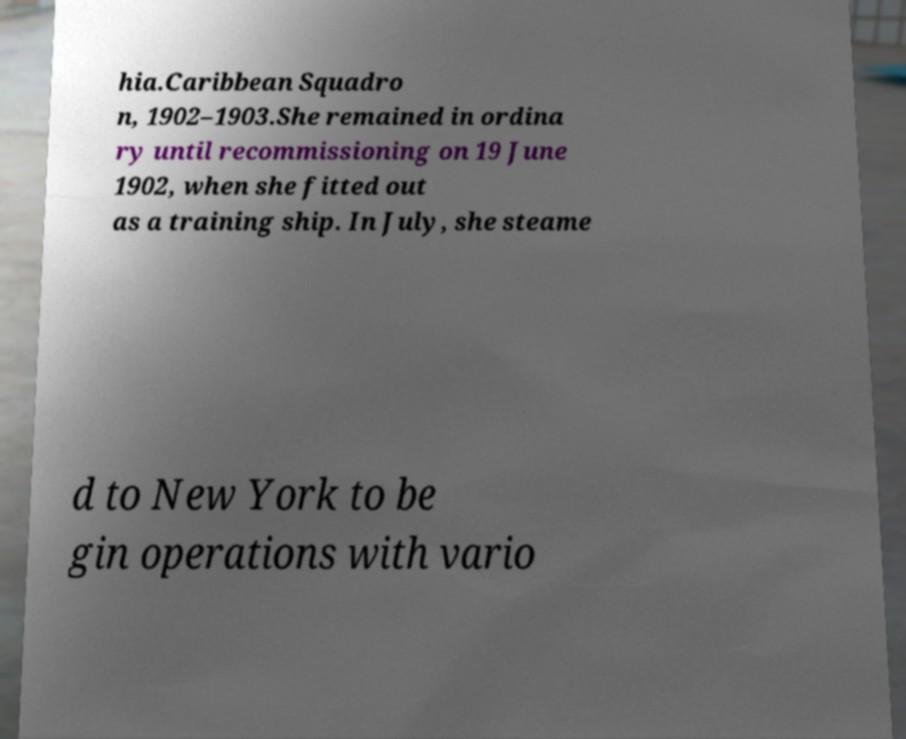There's text embedded in this image that I need extracted. Can you transcribe it verbatim? hia.Caribbean Squadro n, 1902–1903.She remained in ordina ry until recommissioning on 19 June 1902, when she fitted out as a training ship. In July, she steame d to New York to be gin operations with vario 